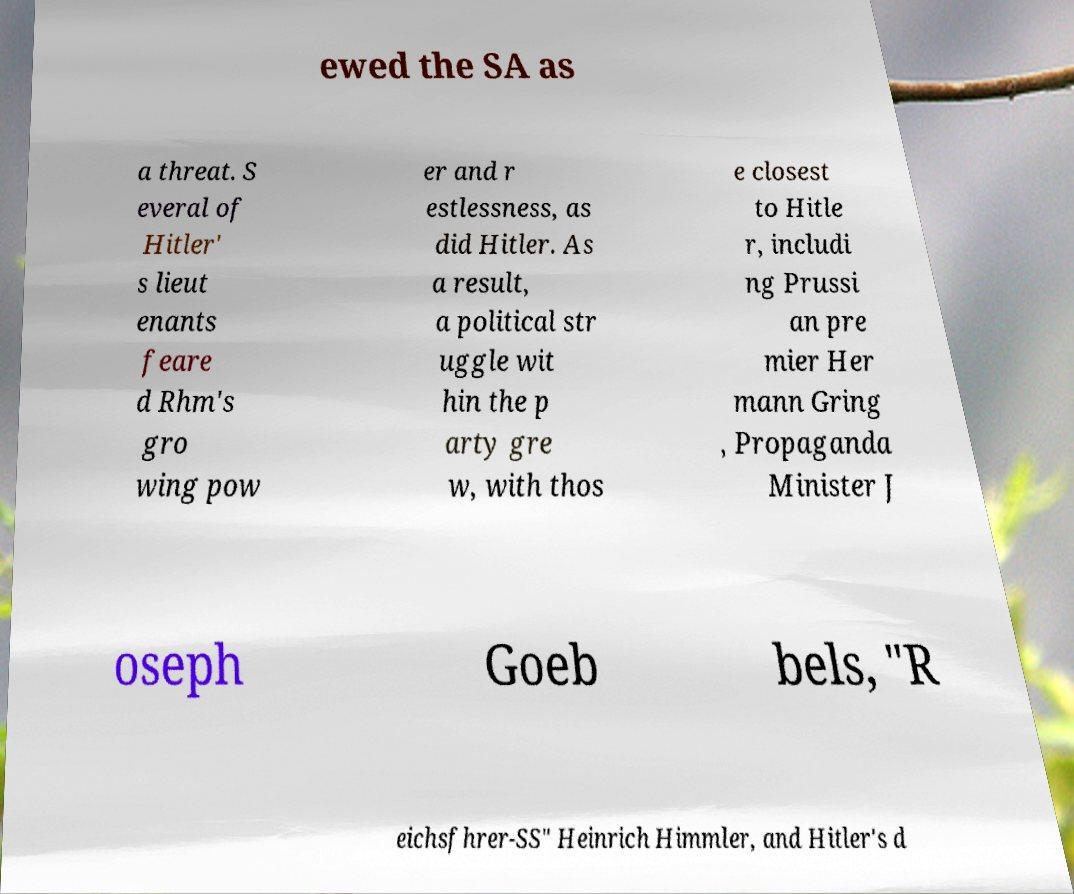What messages or text are displayed in this image? I need them in a readable, typed format. ewed the SA as a threat. S everal of Hitler' s lieut enants feare d Rhm's gro wing pow er and r estlessness, as did Hitler. As a result, a political str uggle wit hin the p arty gre w, with thos e closest to Hitle r, includi ng Prussi an pre mier Her mann Gring , Propaganda Minister J oseph Goeb bels, "R eichsfhrer-SS" Heinrich Himmler, and Hitler's d 